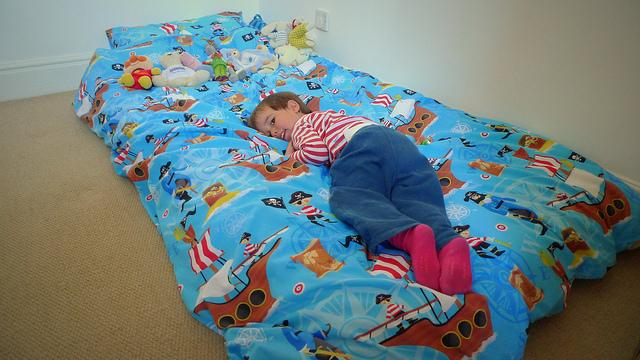Who is joining the boy on his bed?

Choices:
A) parents
B) siblings
C) dogs
D) stuffed animals stuffed animals 